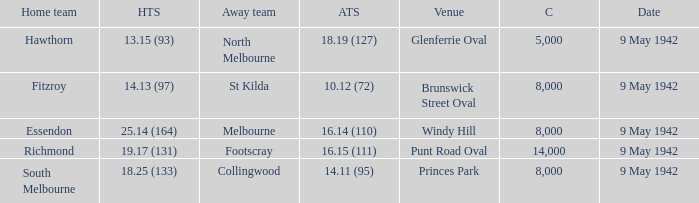How many people attended the game where Footscray was away? 14000.0. 